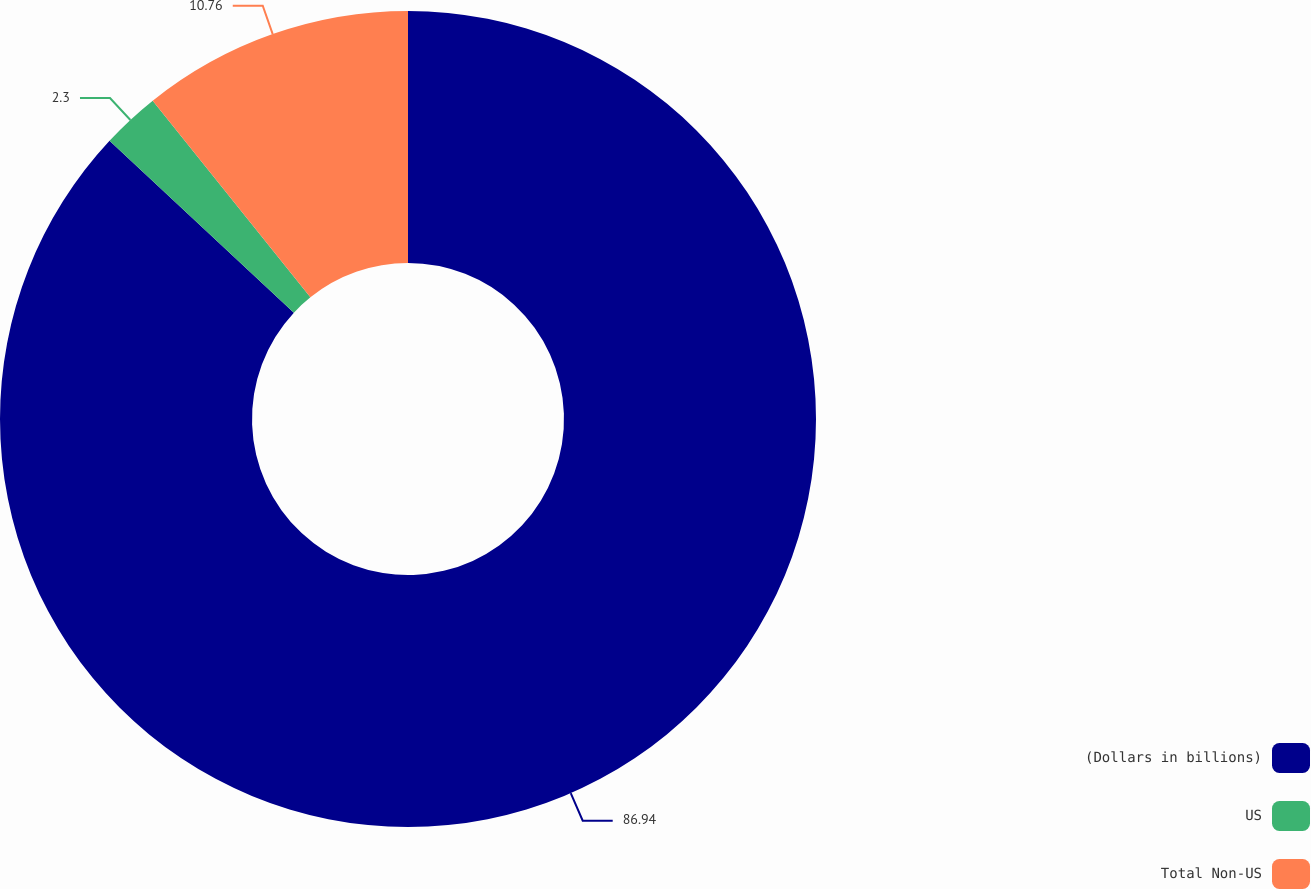Convert chart to OTSL. <chart><loc_0><loc_0><loc_500><loc_500><pie_chart><fcel>(Dollars in billions)<fcel>US<fcel>Total Non-US<nl><fcel>86.94%<fcel>2.3%<fcel>10.76%<nl></chart> 